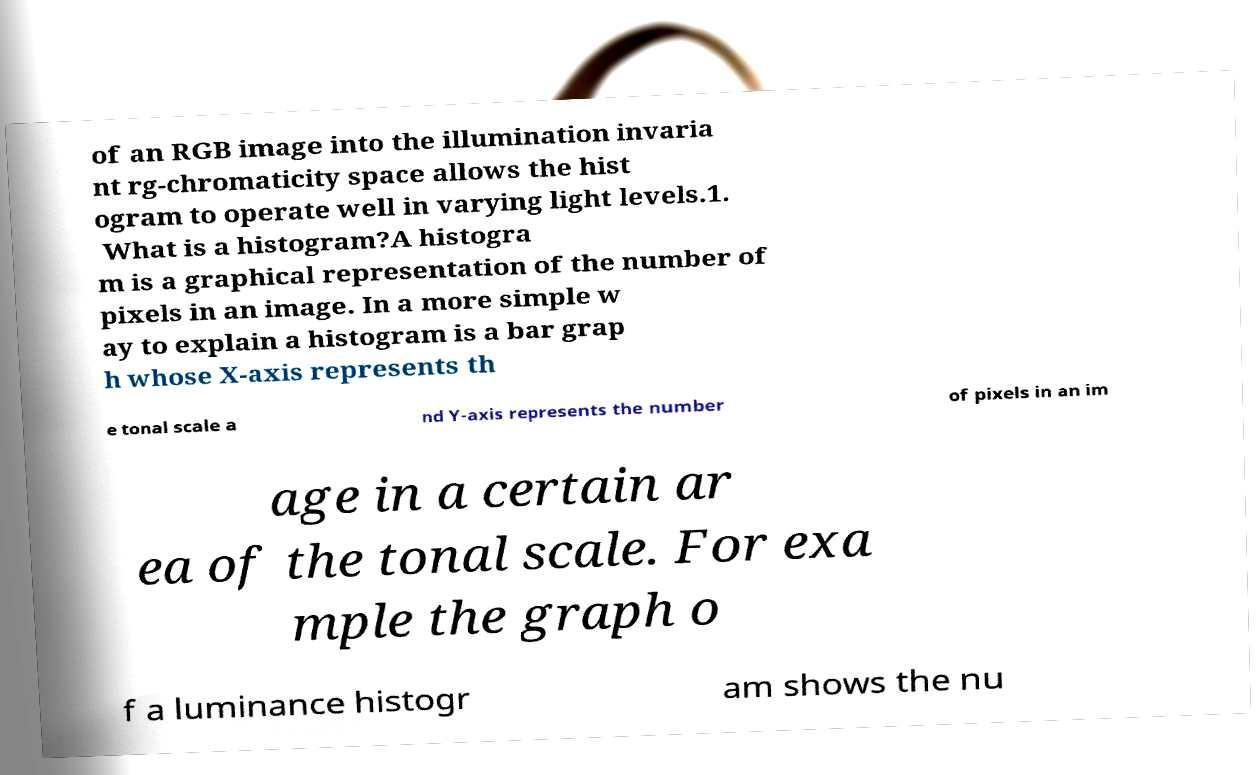For documentation purposes, I need the text within this image transcribed. Could you provide that? of an RGB image into the illumination invaria nt rg-chromaticity space allows the hist ogram to operate well in varying light levels.1. What is a histogram?A histogra m is a graphical representation of the number of pixels in an image. In a more simple w ay to explain a histogram is a bar grap h whose X-axis represents th e tonal scale a nd Y-axis represents the number of pixels in an im age in a certain ar ea of the tonal scale. For exa mple the graph o f a luminance histogr am shows the nu 